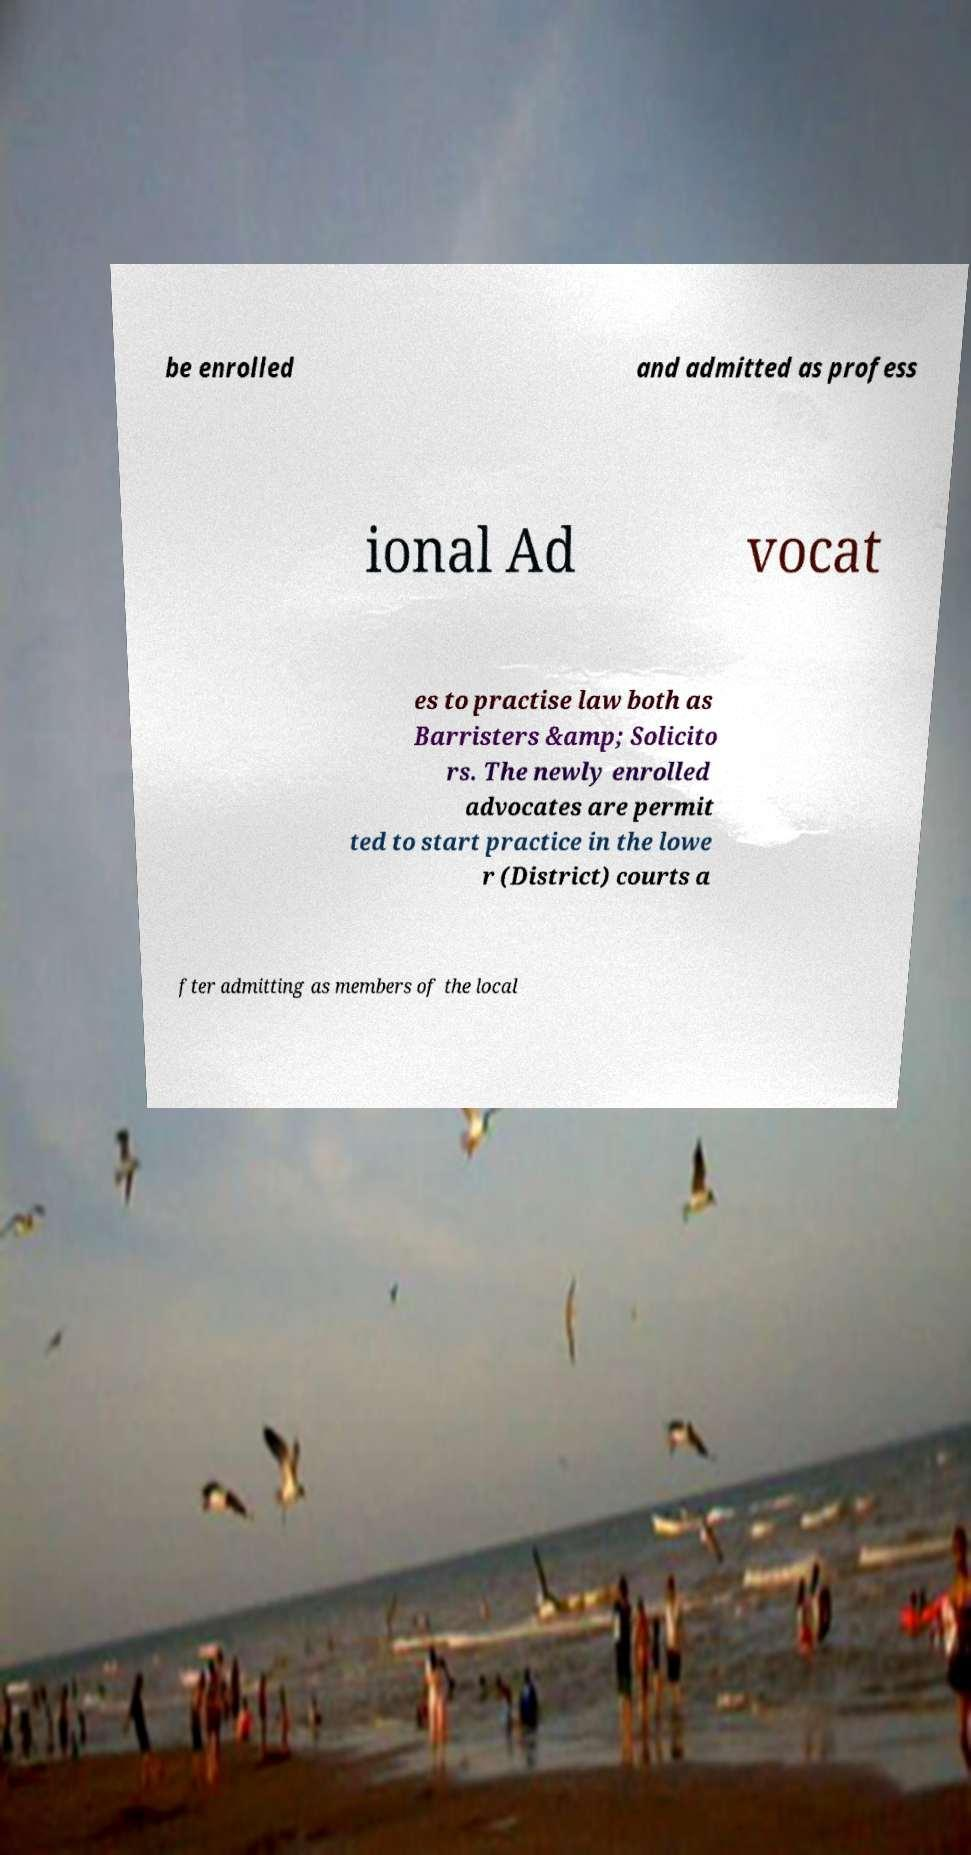Could you assist in decoding the text presented in this image and type it out clearly? be enrolled and admitted as profess ional Ad vocat es to practise law both as Barristers &amp; Solicito rs. The newly enrolled advocates are permit ted to start practice in the lowe r (District) courts a fter admitting as members of the local 